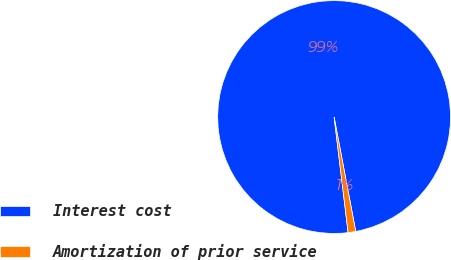<chart> <loc_0><loc_0><loc_500><loc_500><pie_chart><fcel>Interest cost<fcel>Amortization of prior service<nl><fcel>98.94%<fcel>1.06%<nl></chart> 